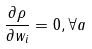<formula> <loc_0><loc_0><loc_500><loc_500>\frac { \partial \rho } { \partial w _ { i } } = 0 , \forall a</formula> 